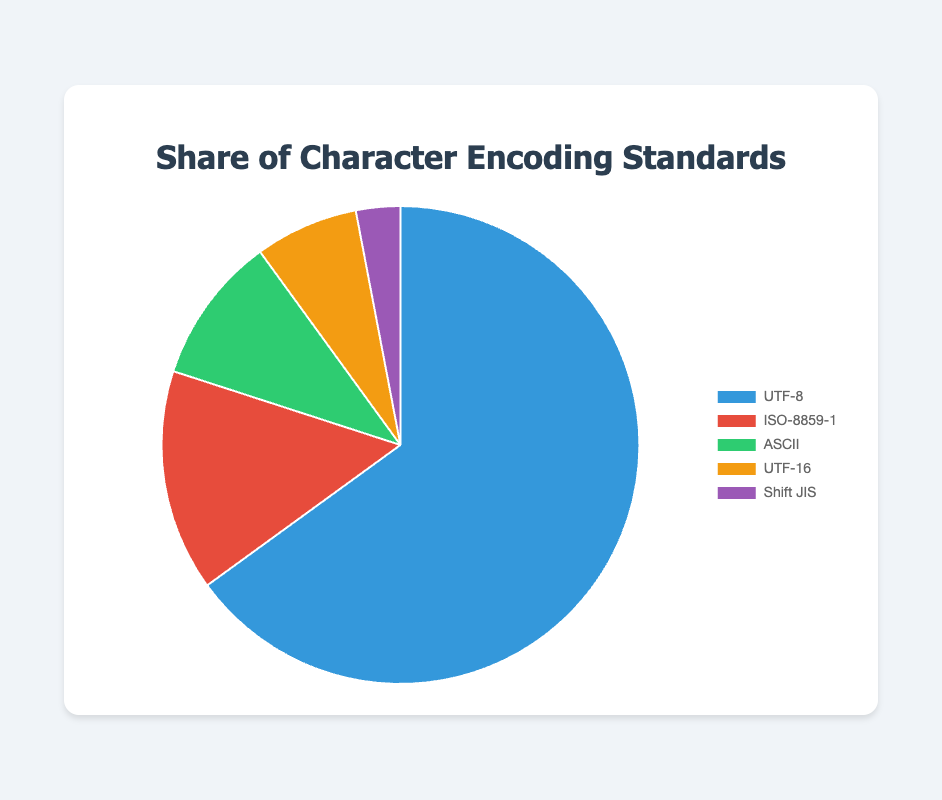Which encoding standard has the largest share? The largest share can be identified by examining which sector occupies the most space in the pie chart. The "UTF-8" segment is the largest.
Answer: UTF-8 What is the combined percentage share of ISO-8859-1 and ASCII? Add the percentages of ISO-8859-1 (15.0) and ASCII (10.0). The sum is 15.0 + 10.0 = 25.0.
Answer: 25.0 How much larger is the share of UTF-8 compared to UTF-16? Subtract the percentage of UTF-16 (7.0) from the percentage of UTF-8 (65.0). The difference is 65.0 - 7.0 = 58.0.
Answer: 58.0 Which encoding standard is represented by a purple color? Identify the sector represented by the purple color in the pie chart. The sector is labeled as "Shift JIS".
Answer: Shift JIS What is the average share of the top three encoding standards? Identify the top three encoding standards by their shares (UTF-8, ISO-8859-1, ASCII) and calculate the average. (65.0 + 15.0 + 10.0) / 3 = 30.0.
Answer: 30.0 Which encoding standard has the smallest share? The smallest share can be identified by examining which sector occupies the least space in the pie chart. The "Shift JIS" segment is the smallest.
Answer: Shift JIS Is the share of ISO-8859-1 less than the combined share of UTF-16 and Shift JIS? Add the percentages of UTF-16 (7.0) and Shift JIS (3.0) to get 7.0 + 3.0 = 10.0, then compare it to ISO-8859-1 (15.0). Since 10.0 < 15.0, the statement is false.
Answer: No Which encoding standard has exactly half the share of ISO-8859-1? Calculate half of ISO-8859-1's share (15.0 / 2 = 7.5) and see if any standard matches this value. No standard has exactly 7.5%.
Answer: None How many encoding standards have a share greater than 5%? Count the sectors representing more than 5%. The standards are UTF-8 (65.0), ISO-8859-1 (15.0), ASCII (10.0), and UTF-16 (7.0). There are 4 such standards.
Answer: 4 